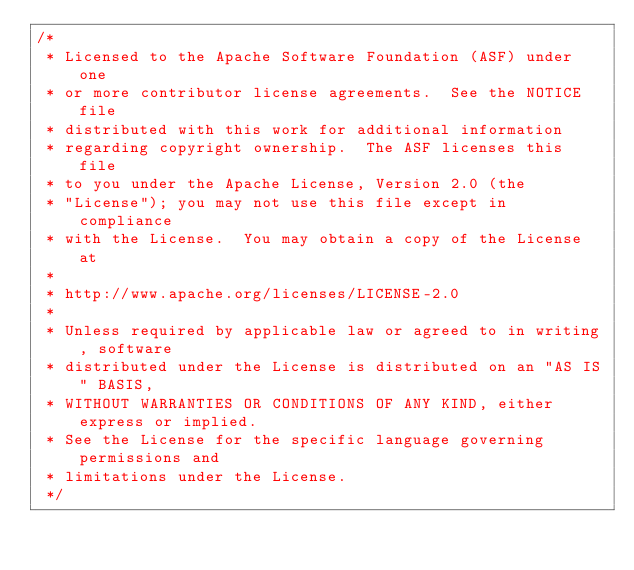<code> <loc_0><loc_0><loc_500><loc_500><_Java_>/*
 * Licensed to the Apache Software Foundation (ASF) under one
 * or more contributor license agreements.  See the NOTICE file
 * distributed with this work for additional information
 * regarding copyright ownership.  The ASF licenses this file
 * to you under the Apache License, Version 2.0 (the
 * "License"); you may not use this file except in compliance
 * with the License.  You may obtain a copy of the License at
 *
 * http://www.apache.org/licenses/LICENSE-2.0
 *
 * Unless required by applicable law or agreed to in writing, software
 * distributed under the License is distributed on an "AS IS" BASIS,
 * WITHOUT WARRANTIES OR CONDITIONS OF ANY KIND, either express or implied.
 * See the License for the specific language governing permissions and
 * limitations under the License.
 */</code> 